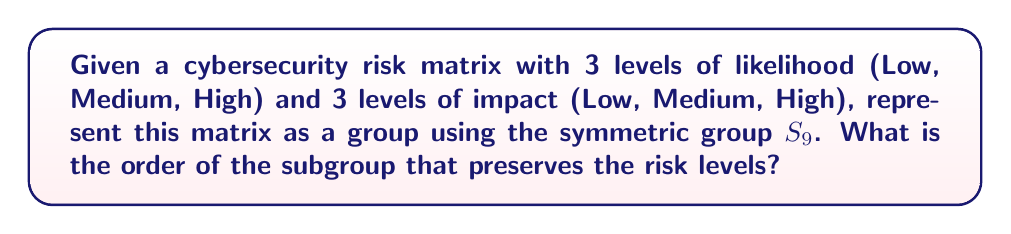Could you help me with this problem? 1. The risk matrix can be represented as a 3x3 grid, with 9 total elements. We can number these elements from 1 to 9.

2. The symmetric group $S_9$ consists of all permutations of these 9 elements.

3. To preserve the risk levels, we need permutations that:
   a) Keep elements within their original row (preserving likelihood)
   b) Keep elements within their original column (preserving impact)

4. This means we can independently permute:
   a) The 3 rows (3! ways)
   b) The 3 columns (3! ways)
   c) The 3 elements within each of the 9 cells (3!^9 ways)

5. By the multiplication principle, the total number of permutations preserving risk levels is:

   $$ 3! \cdot 3! \cdot (3!)^9 $$

6. Calculating this:
   $$ 6 \cdot 6 \cdot (6^9) = 36 \cdot 6^9 = 36 \cdot 10,077,696 = 362,797,056 $$

7. This number represents the order of the subgroup of $S_9$ that preserves the risk levels in our cybersecurity risk matrix.
Answer: 362,797,056 